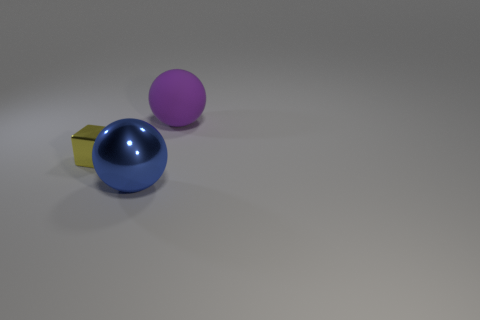Is there anything else that is the same size as the yellow block?
Provide a succinct answer. No. Is there anything else that has the same material as the large purple thing?
Your answer should be very brief. No. Are there any big purple rubber objects that have the same shape as the big blue thing?
Your answer should be very brief. Yes. Do the purple rubber object and the blue thing have the same shape?
Keep it short and to the point. Yes. What number of large objects are either purple objects or yellow matte cylinders?
Your answer should be compact. 1. Is the number of big blue things greater than the number of metal objects?
Make the answer very short. No. There is another object that is made of the same material as the yellow thing; what size is it?
Your answer should be compact. Large. There is a ball that is in front of the purple matte ball; does it have the same size as the metal thing behind the big blue metal ball?
Give a very brief answer. No. What number of objects are either big objects that are left of the purple matte sphere or small red metallic blocks?
Your answer should be very brief. 1. Is the number of big rubber things less than the number of green matte cylinders?
Offer a terse response. No. 